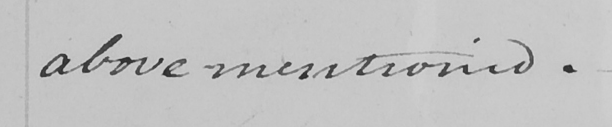Please transcribe the handwritten text in this image. above mentioned . _ 